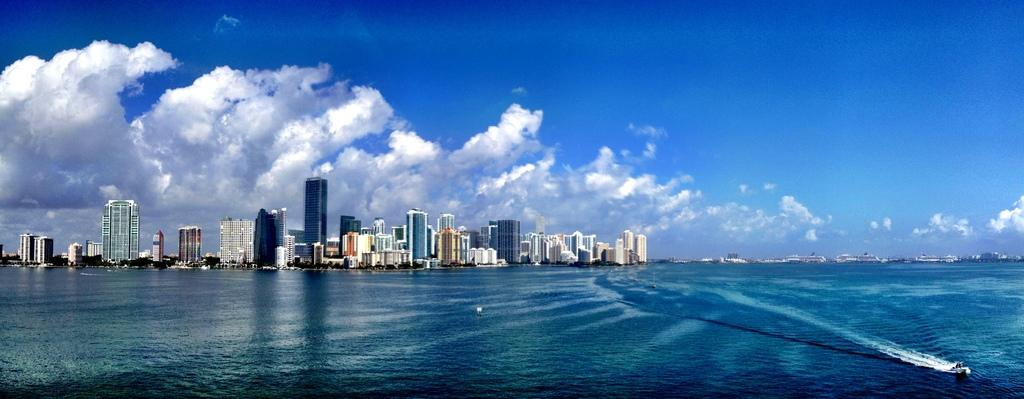What type of structures can be seen in the background of the image? There are buildings in the background of the image. What else is visible in the background of the image? The sky and clouds are present in the background of the image. What is in the foreground of the image? There is water in the foreground of the image. What is the main subject in the image? There is a ship in the image. What type of boundary can be seen in the image? There is no boundary present in the image. What emotion is represented by the ship in the image? The image does not convey emotions, and the ship is simply a subject in the image. 